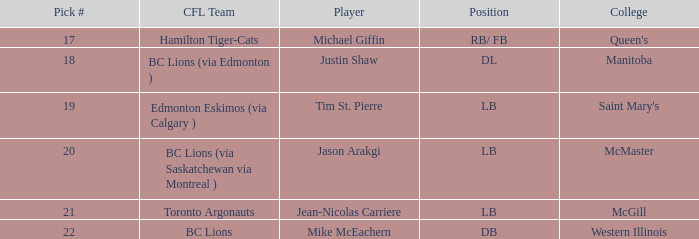What position is Justin Shaw in? DL. 